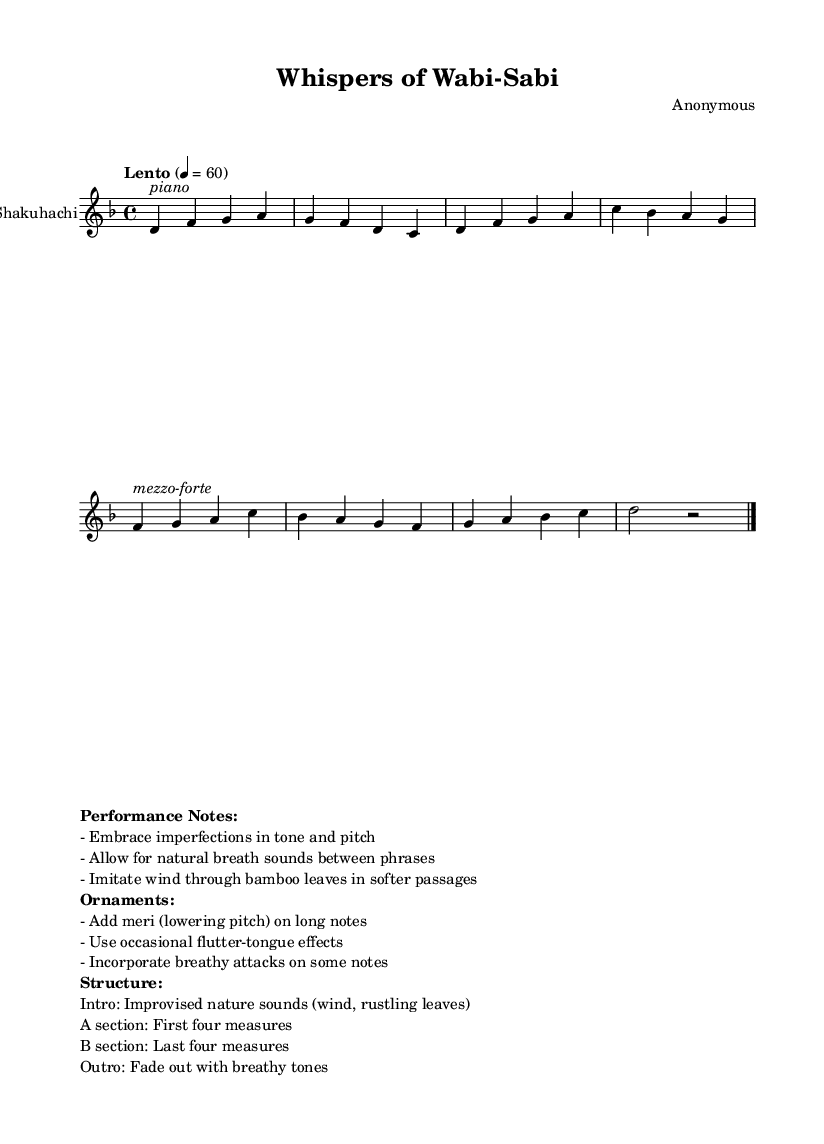What is the key signature of this music? The key signature is indicated at the beginning of the score, showing one flat which corresponds to the key of D minor.
Answer: D minor What is the time signature of this piece? The time signature is found at the beginning of the score, shown as 4/4, meaning there are four beats in each measure.
Answer: 4/4 What tempo indication is given in the score? The tempo marking is specified in the score with the word "Lento" and a metronome mark of 60 beats per minute, indicating a slow pace.
Answer: Lento, 60 How many measures are in the A section of the music? The A section is specified as the first four measures of the score, which can be counted directly from the notation.
Answer: Four measures What performance notes emphasize the use of breath sounds? The performance notes specifically instruct the performer to allow for natural breath sounds between phrases, suggesting an organic stylistic approach.
Answer: Natural breath sounds What unique ornamentation technique is suggested to be used in this piece? The performance notes mention "meri," which refers to the technique of lowering the pitch on long notes, highlighting an essential characteristic of shakuhachi playing.
Answer: Meri How does the structure of this music reflect Wabi-Sabi principles? The structure includes an intro with improvised nature sounds, which resonates with Wabi-Sabi by embracing natural, imperfect elements, and a fade-out outro, symbolizing transience.
Answer: Improvised nature sounds 